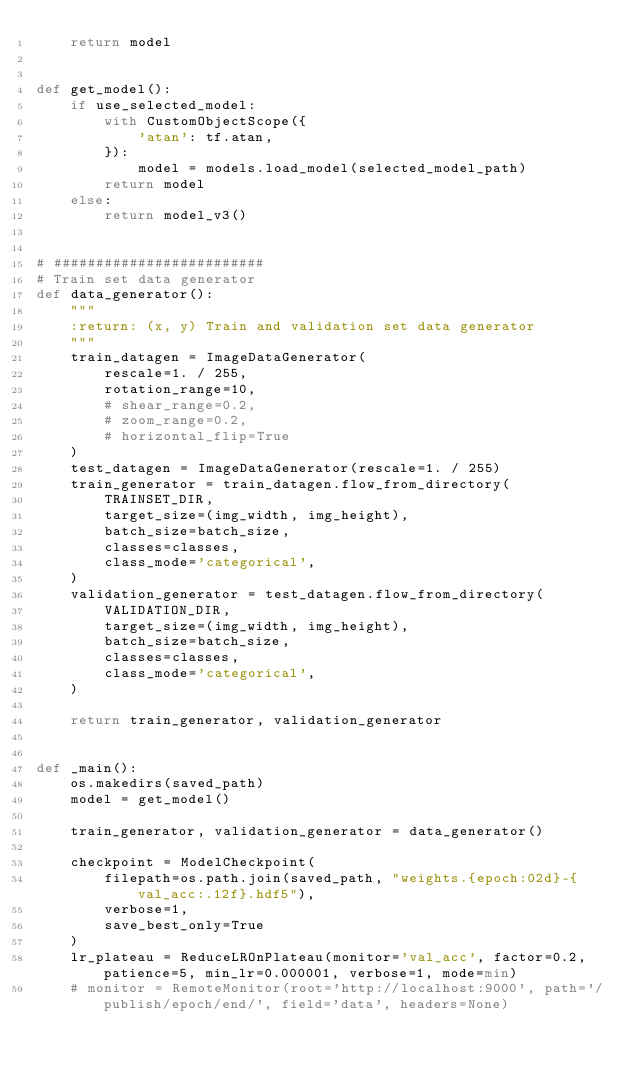<code> <loc_0><loc_0><loc_500><loc_500><_Python_>    return model


def get_model():
    if use_selected_model:
        with CustomObjectScope({
            'atan': tf.atan,
        }):
            model = models.load_model(selected_model_path)
        return model
    else:
        return model_v3()


# #########################
# Train set data generator
def data_generator():
    """
    :return: (x, y) Train and validation set data generator
    """
    train_datagen = ImageDataGenerator(
        rescale=1. / 255,
        rotation_range=10,
        # shear_range=0.2,
        # zoom_range=0.2,
        # horizontal_flip=True
    )
    test_datagen = ImageDataGenerator(rescale=1. / 255)
    train_generator = train_datagen.flow_from_directory(
        TRAINSET_DIR,
        target_size=(img_width, img_height),
        batch_size=batch_size,
        classes=classes,
        class_mode='categorical',
    )
    validation_generator = test_datagen.flow_from_directory(
        VALIDATION_DIR,
        target_size=(img_width, img_height),
        batch_size=batch_size,
        classes=classes,
        class_mode='categorical',
    )

    return train_generator, validation_generator


def _main():
    os.makedirs(saved_path)
    model = get_model()

    train_generator, validation_generator = data_generator()

    checkpoint = ModelCheckpoint(
        filepath=os.path.join(saved_path, "weights.{epoch:02d}-{val_acc:.12f}.hdf5"),
        verbose=1,
        save_best_only=True
    )
    lr_plateau = ReduceLROnPlateau(monitor='val_acc', factor=0.2, patience=5, min_lr=0.000001, verbose=1, mode=min)
    # monitor = RemoteMonitor(root='http://localhost:9000', path='/publish/epoch/end/', field='data', headers=None)
</code> 